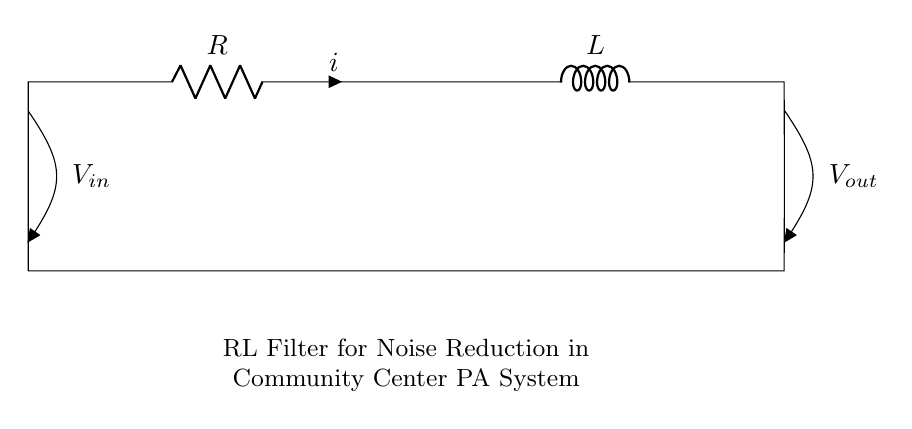What is the component labeled R? The component labeled R is a resistor, which is used to limit current flow in the circuit.
Answer: Resistor What is the purpose of the inductor in this circuit? The inductor is used to store energy in a magnetic field and helps filter out high-frequency noise, improving the sound quality in the public address system.
Answer: Noise reduction What are the input and output voltage labels in the circuit? The input voltage is labeled as V_in and the output voltage is labeled as V_out, representing the voltage before and after the signal passes through the circuit.
Answer: V_in and V_out How many components are in the circuit? There are two main components in the circuit: one resistor and one inductor, which are connected in series.
Answer: Two What happens to high-frequency signals in this RL filter? High-frequency signals are significantly reduced by the circuit due to the inductor's impedance increasing with frequency, while low-frequency signals are allowed to pass.
Answer: Attenuated What is the relationship between the current and the resistor in this circuit? The current passing through the resistor is labeled as i, and according to Ohm's law, it will have a direct relationship with the voltage across the resistor, as the resistor will drop voltage proportional to the current flowing through it.
Answer: Current i 